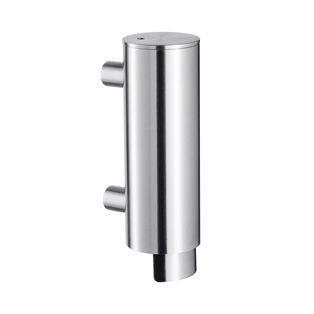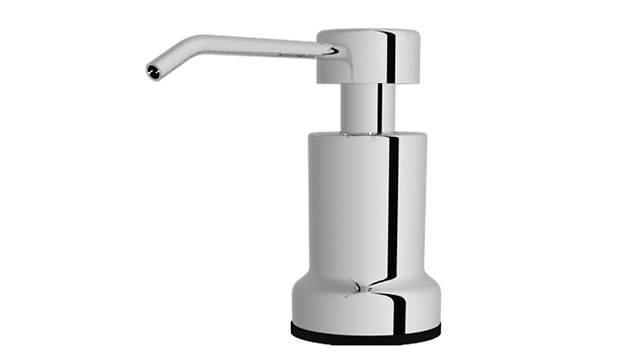The first image is the image on the left, the second image is the image on the right. Evaluate the accuracy of this statement regarding the images: "In one of the images, there is a manual soap dispenser with a nozzle facing left.". Is it true? Answer yes or no. Yes. The first image is the image on the left, the second image is the image on the right. Assess this claim about the two images: "wall soap dispensers and pumps". Correct or not? Answer yes or no. No. 